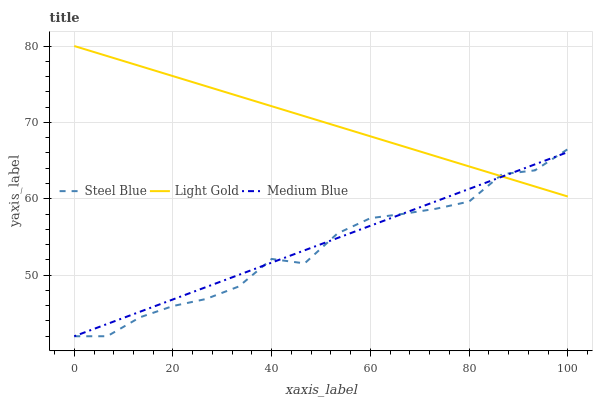Does Steel Blue have the minimum area under the curve?
Answer yes or no. Yes. Does Light Gold have the maximum area under the curve?
Answer yes or no. Yes. Does Light Gold have the minimum area under the curve?
Answer yes or no. No. Does Steel Blue have the maximum area under the curve?
Answer yes or no. No. Is Medium Blue the smoothest?
Answer yes or no. Yes. Is Steel Blue the roughest?
Answer yes or no. Yes. Is Light Gold the smoothest?
Answer yes or no. No. Is Light Gold the roughest?
Answer yes or no. No. Does Medium Blue have the lowest value?
Answer yes or no. Yes. Does Light Gold have the lowest value?
Answer yes or no. No. Does Light Gold have the highest value?
Answer yes or no. Yes. Does Steel Blue have the highest value?
Answer yes or no. No. Does Light Gold intersect Steel Blue?
Answer yes or no. Yes. Is Light Gold less than Steel Blue?
Answer yes or no. No. Is Light Gold greater than Steel Blue?
Answer yes or no. No. 